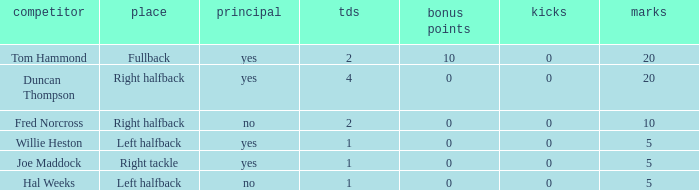How many field goals did duncan thompson have? 0.0. 